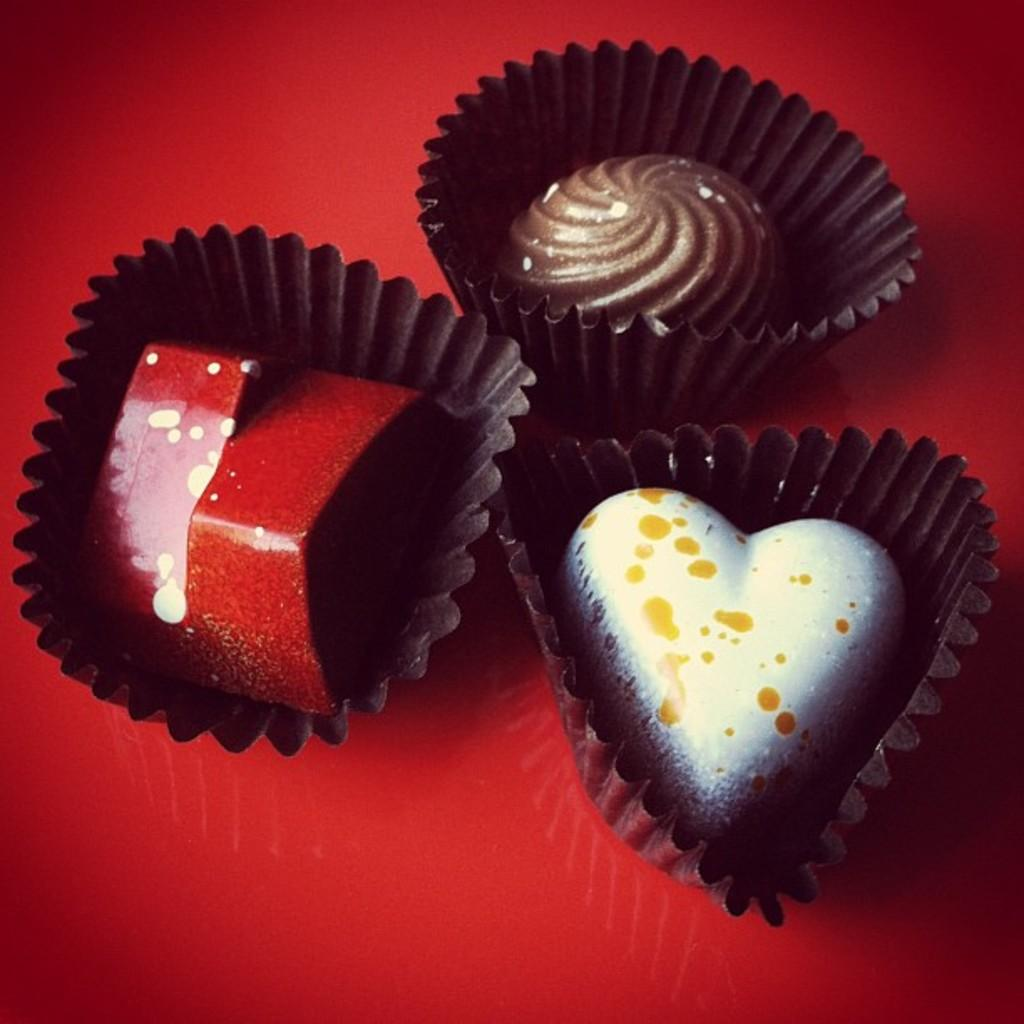What type of food is shown in the image? There are cupcakes in the image. What color is the surface on which the cupcakes are placed? The cupcakes are on a red surface. What color are the cupcake cups? The cupcake cups are black. How many different colors can be seen on the cupcakes? The cupcakes have four different colors: red, brown, yellow, and white. Can you tell me how many times the girl in the image has visited her grandmother? There is no girl or grandmother present in the image; it only features cupcakes on a red surface. 